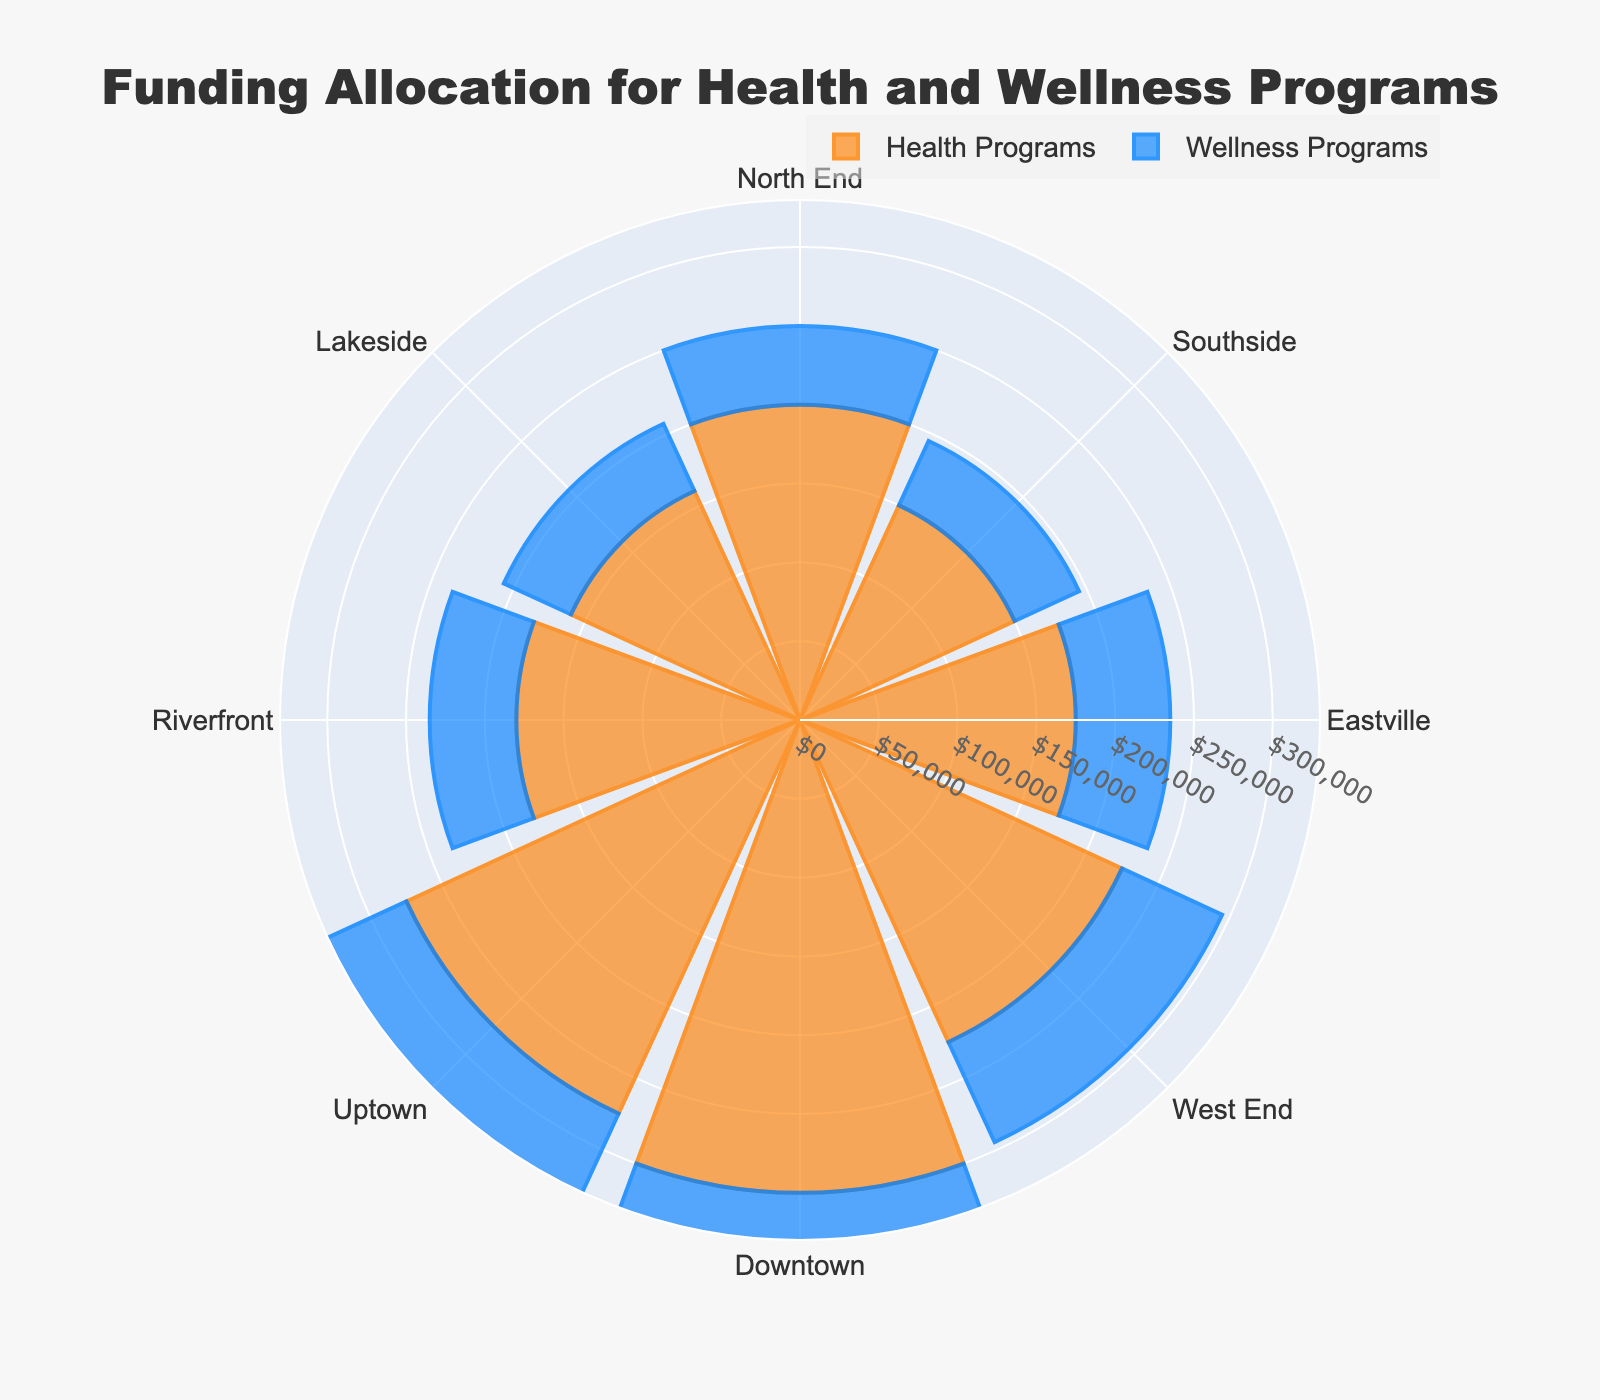What's the title of the figure? The title is located at the top center of the chart, shown prominently in large and bold font.
Answer: Funding Allocation for Health and Wellness Programs Which district has the highest funding allocation for Health Programs? By observing the length of the bars in the chart, Downtown has the longest bar for Health Programs.
Answer: Downtown Which district received more funding for Wellness Programs: North End or Riverfront? By comparing the length of the bars for Wellness Programs in North End and Riverfront, Riverfront’s bar is slightly longer.
Answer: Riverfront What is the total funding allocation for Wellness Programs across all districts? Sum the funding allocations for Wellness Programs from all districts: 50,000 + 45,000 + 60,000 + 70,000 + 80,000 + 65,000 + 55,000 + 47,000 = 472,000.
Answer: 472,000 How does the funding allocation for Health Programs in Uptown compare to Southside? The bar length for Health Programs in Uptown is significantly longer than that of Southside.
Answer: Uptown has more funding Which district has the least funding for both Health and Wellness Programs combined? Calculate the sum of funding for Health and Wellness Programs in each district and compare: North End (250,000), Southside (195,000), Eastville (235,000), West End (295,000), Downtown (380,000), Uptown (340,000), Riverfront (235,000), Lakeside (207,000). Southside has the smallest total.
Answer: Southside What is the average funding allocation for Health Programs across all districts? Sum the funding allocations for Health Programs and divide by the number of districts: (200,000 + 150,000 + 175,000 + 225,000 + 300,000 + 275,000 + 180,000 + 160,000)/8 = 208,125.
Answer: 208,125 Does Lakeside receive more funding for Health Programs or Wellness Programs? By comparing the length of the bars for Health and Wellness Programs in Lakeside, the bar for Health Programs is longer.
Answer: Health Programs Which district shows the most balanced allocation between Health and Wellness Programs? Look for the district where the bars for Health and Wellness Programs are most similar in length. Uptown's bars for Health and Wellness Programs seem closest in length.
Answer: Uptown 